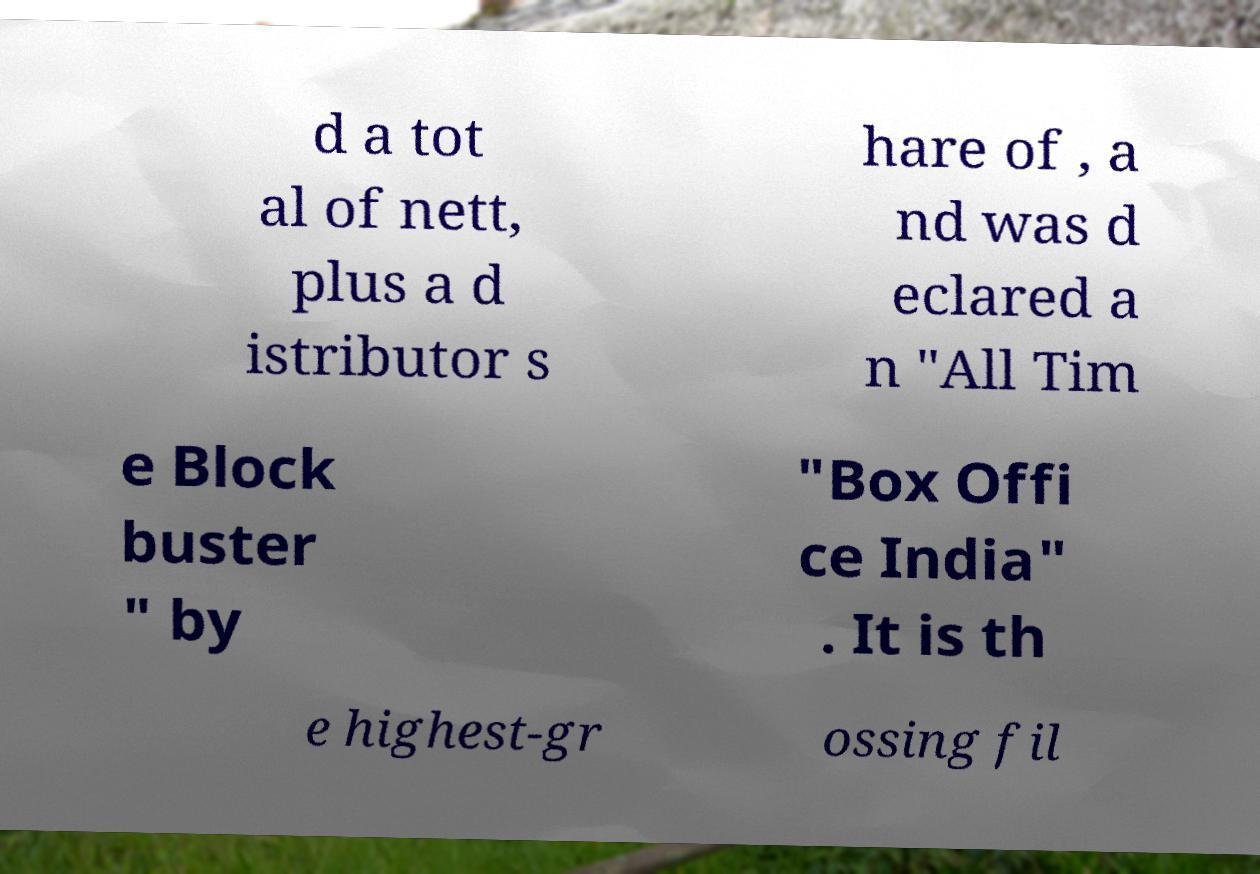I need the written content from this picture converted into text. Can you do that? d a tot al of nett, plus a d istributor s hare of , a nd was d eclared a n "All Tim e Block buster " by "Box Offi ce India" . It is th e highest-gr ossing fil 